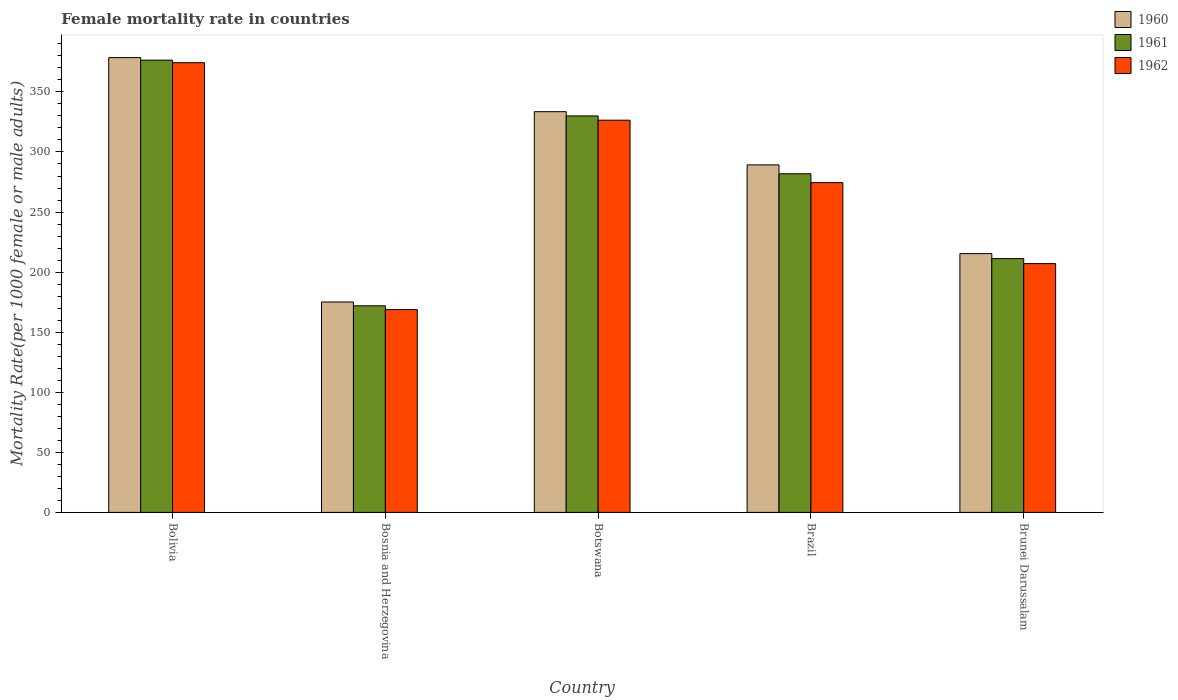How many different coloured bars are there?
Your answer should be very brief. 3. How many groups of bars are there?
Ensure brevity in your answer.  5. How many bars are there on the 4th tick from the right?
Your answer should be compact. 3. What is the label of the 1st group of bars from the left?
Ensure brevity in your answer.  Bolivia. What is the female mortality rate in 1961 in Brunei Darussalam?
Provide a short and direct response. 211.24. Across all countries, what is the maximum female mortality rate in 1961?
Provide a succinct answer. 376.43. Across all countries, what is the minimum female mortality rate in 1960?
Offer a terse response. 175.12. In which country was the female mortality rate in 1961 maximum?
Provide a short and direct response. Bolivia. In which country was the female mortality rate in 1961 minimum?
Ensure brevity in your answer.  Bosnia and Herzegovina. What is the total female mortality rate in 1961 in the graph?
Keep it short and to the point. 1371.52. What is the difference between the female mortality rate in 1961 in Botswana and that in Brazil?
Offer a very short reply. 48.13. What is the difference between the female mortality rate in 1960 in Brunei Darussalam and the female mortality rate in 1962 in Bosnia and Herzegovina?
Your answer should be very brief. 46.57. What is the average female mortality rate in 1962 per country?
Provide a succinct answer. 270.24. What is the difference between the female mortality rate of/in 1961 and female mortality rate of/in 1962 in Bolivia?
Offer a terse response. 2.11. What is the ratio of the female mortality rate in 1960 in Bolivia to that in Brazil?
Make the answer very short. 1.31. Is the difference between the female mortality rate in 1961 in Bolivia and Botswana greater than the difference between the female mortality rate in 1962 in Bolivia and Botswana?
Your response must be concise. No. What is the difference between the highest and the second highest female mortality rate in 1961?
Offer a very short reply. 46.43. What is the difference between the highest and the lowest female mortality rate in 1961?
Provide a short and direct response. 204.45. Is the sum of the female mortality rate in 1961 in Bolivia and Brunei Darussalam greater than the maximum female mortality rate in 1960 across all countries?
Ensure brevity in your answer.  Yes. What does the 3rd bar from the left in Botswana represents?
Offer a very short reply. 1962. What does the 1st bar from the right in Brunei Darussalam represents?
Keep it short and to the point. 1962. Is it the case that in every country, the sum of the female mortality rate in 1962 and female mortality rate in 1960 is greater than the female mortality rate in 1961?
Provide a short and direct response. Yes. How many bars are there?
Make the answer very short. 15. How many countries are there in the graph?
Provide a succinct answer. 5. Are the values on the major ticks of Y-axis written in scientific E-notation?
Ensure brevity in your answer.  No. How are the legend labels stacked?
Your answer should be very brief. Vertical. What is the title of the graph?
Offer a terse response. Female mortality rate in countries. Does "1964" appear as one of the legend labels in the graph?
Offer a terse response. No. What is the label or title of the Y-axis?
Make the answer very short. Mortality Rate(per 1000 female or male adults). What is the Mortality Rate(per 1000 female or male adults) in 1960 in Bolivia?
Provide a short and direct response. 378.54. What is the Mortality Rate(per 1000 female or male adults) in 1961 in Bolivia?
Give a very brief answer. 376.43. What is the Mortality Rate(per 1000 female or male adults) of 1962 in Bolivia?
Offer a terse response. 374.32. What is the Mortality Rate(per 1000 female or male adults) in 1960 in Bosnia and Herzegovina?
Give a very brief answer. 175.12. What is the Mortality Rate(per 1000 female or male adults) in 1961 in Bosnia and Herzegovina?
Your response must be concise. 171.98. What is the Mortality Rate(per 1000 female or male adults) in 1962 in Bosnia and Herzegovina?
Make the answer very short. 168.83. What is the Mortality Rate(per 1000 female or male adults) of 1960 in Botswana?
Ensure brevity in your answer.  333.54. What is the Mortality Rate(per 1000 female or male adults) of 1961 in Botswana?
Provide a succinct answer. 330. What is the Mortality Rate(per 1000 female or male adults) of 1962 in Botswana?
Your answer should be very brief. 326.45. What is the Mortality Rate(per 1000 female or male adults) in 1960 in Brazil?
Offer a very short reply. 289.25. What is the Mortality Rate(per 1000 female or male adults) in 1961 in Brazil?
Provide a short and direct response. 281.87. What is the Mortality Rate(per 1000 female or male adults) in 1962 in Brazil?
Give a very brief answer. 274.49. What is the Mortality Rate(per 1000 female or male adults) in 1960 in Brunei Darussalam?
Offer a very short reply. 215.4. What is the Mortality Rate(per 1000 female or male adults) in 1961 in Brunei Darussalam?
Keep it short and to the point. 211.24. What is the Mortality Rate(per 1000 female or male adults) in 1962 in Brunei Darussalam?
Offer a very short reply. 207.09. Across all countries, what is the maximum Mortality Rate(per 1000 female or male adults) in 1960?
Your answer should be compact. 378.54. Across all countries, what is the maximum Mortality Rate(per 1000 female or male adults) of 1961?
Give a very brief answer. 376.43. Across all countries, what is the maximum Mortality Rate(per 1000 female or male adults) of 1962?
Provide a succinct answer. 374.32. Across all countries, what is the minimum Mortality Rate(per 1000 female or male adults) in 1960?
Give a very brief answer. 175.12. Across all countries, what is the minimum Mortality Rate(per 1000 female or male adults) of 1961?
Give a very brief answer. 171.98. Across all countries, what is the minimum Mortality Rate(per 1000 female or male adults) in 1962?
Your answer should be compact. 168.83. What is the total Mortality Rate(per 1000 female or male adults) of 1960 in the graph?
Provide a short and direct response. 1391.86. What is the total Mortality Rate(per 1000 female or male adults) in 1961 in the graph?
Offer a terse response. 1371.52. What is the total Mortality Rate(per 1000 female or male adults) of 1962 in the graph?
Your answer should be compact. 1351.18. What is the difference between the Mortality Rate(per 1000 female or male adults) in 1960 in Bolivia and that in Bosnia and Herzegovina?
Provide a succinct answer. 203.42. What is the difference between the Mortality Rate(per 1000 female or male adults) of 1961 in Bolivia and that in Bosnia and Herzegovina?
Provide a short and direct response. 204.45. What is the difference between the Mortality Rate(per 1000 female or male adults) in 1962 in Bolivia and that in Bosnia and Herzegovina?
Your answer should be compact. 205.49. What is the difference between the Mortality Rate(per 1000 female or male adults) in 1960 in Bolivia and that in Botswana?
Make the answer very short. 45. What is the difference between the Mortality Rate(per 1000 female or male adults) of 1961 in Bolivia and that in Botswana?
Make the answer very short. 46.43. What is the difference between the Mortality Rate(per 1000 female or male adults) in 1962 in Bolivia and that in Botswana?
Keep it short and to the point. 47.86. What is the difference between the Mortality Rate(per 1000 female or male adults) in 1960 in Bolivia and that in Brazil?
Keep it short and to the point. 89.29. What is the difference between the Mortality Rate(per 1000 female or male adults) in 1961 in Bolivia and that in Brazil?
Your answer should be very brief. 94.56. What is the difference between the Mortality Rate(per 1000 female or male adults) of 1962 in Bolivia and that in Brazil?
Give a very brief answer. 99.83. What is the difference between the Mortality Rate(per 1000 female or male adults) of 1960 in Bolivia and that in Brunei Darussalam?
Provide a short and direct response. 163.14. What is the difference between the Mortality Rate(per 1000 female or male adults) of 1961 in Bolivia and that in Brunei Darussalam?
Offer a terse response. 165.19. What is the difference between the Mortality Rate(per 1000 female or male adults) in 1962 in Bolivia and that in Brunei Darussalam?
Your answer should be compact. 167.23. What is the difference between the Mortality Rate(per 1000 female or male adults) of 1960 in Bosnia and Herzegovina and that in Botswana?
Your answer should be very brief. -158.42. What is the difference between the Mortality Rate(per 1000 female or male adults) in 1961 in Bosnia and Herzegovina and that in Botswana?
Keep it short and to the point. -158.02. What is the difference between the Mortality Rate(per 1000 female or male adults) of 1962 in Bosnia and Herzegovina and that in Botswana?
Your response must be concise. -157.62. What is the difference between the Mortality Rate(per 1000 female or male adults) in 1960 in Bosnia and Herzegovina and that in Brazil?
Provide a succinct answer. -114.13. What is the difference between the Mortality Rate(per 1000 female or male adults) in 1961 in Bosnia and Herzegovina and that in Brazil?
Your answer should be very brief. -109.9. What is the difference between the Mortality Rate(per 1000 female or male adults) in 1962 in Bosnia and Herzegovina and that in Brazil?
Your answer should be compact. -105.66. What is the difference between the Mortality Rate(per 1000 female or male adults) of 1960 in Bosnia and Herzegovina and that in Brunei Darussalam?
Offer a terse response. -40.27. What is the difference between the Mortality Rate(per 1000 female or male adults) in 1961 in Bosnia and Herzegovina and that in Brunei Darussalam?
Ensure brevity in your answer.  -39.27. What is the difference between the Mortality Rate(per 1000 female or male adults) in 1962 in Bosnia and Herzegovina and that in Brunei Darussalam?
Give a very brief answer. -38.26. What is the difference between the Mortality Rate(per 1000 female or male adults) in 1960 in Botswana and that in Brazil?
Your response must be concise. 44.29. What is the difference between the Mortality Rate(per 1000 female or male adults) in 1961 in Botswana and that in Brazil?
Offer a very short reply. 48.13. What is the difference between the Mortality Rate(per 1000 female or male adults) of 1962 in Botswana and that in Brazil?
Ensure brevity in your answer.  51.96. What is the difference between the Mortality Rate(per 1000 female or male adults) in 1960 in Botswana and that in Brunei Darussalam?
Offer a terse response. 118.14. What is the difference between the Mortality Rate(per 1000 female or male adults) of 1961 in Botswana and that in Brunei Darussalam?
Your answer should be very brief. 118.76. What is the difference between the Mortality Rate(per 1000 female or male adults) of 1962 in Botswana and that in Brunei Darussalam?
Make the answer very short. 119.37. What is the difference between the Mortality Rate(per 1000 female or male adults) of 1960 in Brazil and that in Brunei Darussalam?
Give a very brief answer. 73.86. What is the difference between the Mortality Rate(per 1000 female or male adults) of 1961 in Brazil and that in Brunei Darussalam?
Offer a terse response. 70.63. What is the difference between the Mortality Rate(per 1000 female or male adults) in 1962 in Brazil and that in Brunei Darussalam?
Provide a short and direct response. 67.41. What is the difference between the Mortality Rate(per 1000 female or male adults) of 1960 in Bolivia and the Mortality Rate(per 1000 female or male adults) of 1961 in Bosnia and Herzegovina?
Your response must be concise. 206.57. What is the difference between the Mortality Rate(per 1000 female or male adults) in 1960 in Bolivia and the Mortality Rate(per 1000 female or male adults) in 1962 in Bosnia and Herzegovina?
Make the answer very short. 209.71. What is the difference between the Mortality Rate(per 1000 female or male adults) of 1961 in Bolivia and the Mortality Rate(per 1000 female or male adults) of 1962 in Bosnia and Herzegovina?
Offer a very short reply. 207.6. What is the difference between the Mortality Rate(per 1000 female or male adults) of 1960 in Bolivia and the Mortality Rate(per 1000 female or male adults) of 1961 in Botswana?
Give a very brief answer. 48.54. What is the difference between the Mortality Rate(per 1000 female or male adults) of 1960 in Bolivia and the Mortality Rate(per 1000 female or male adults) of 1962 in Botswana?
Give a very brief answer. 52.09. What is the difference between the Mortality Rate(per 1000 female or male adults) in 1961 in Bolivia and the Mortality Rate(per 1000 female or male adults) in 1962 in Botswana?
Make the answer very short. 49.98. What is the difference between the Mortality Rate(per 1000 female or male adults) of 1960 in Bolivia and the Mortality Rate(per 1000 female or male adults) of 1961 in Brazil?
Your answer should be compact. 96.67. What is the difference between the Mortality Rate(per 1000 female or male adults) of 1960 in Bolivia and the Mortality Rate(per 1000 female or male adults) of 1962 in Brazil?
Give a very brief answer. 104.05. What is the difference between the Mortality Rate(per 1000 female or male adults) of 1961 in Bolivia and the Mortality Rate(per 1000 female or male adults) of 1962 in Brazil?
Your answer should be compact. 101.94. What is the difference between the Mortality Rate(per 1000 female or male adults) in 1960 in Bolivia and the Mortality Rate(per 1000 female or male adults) in 1961 in Brunei Darussalam?
Give a very brief answer. 167.3. What is the difference between the Mortality Rate(per 1000 female or male adults) of 1960 in Bolivia and the Mortality Rate(per 1000 female or male adults) of 1962 in Brunei Darussalam?
Keep it short and to the point. 171.46. What is the difference between the Mortality Rate(per 1000 female or male adults) in 1961 in Bolivia and the Mortality Rate(per 1000 female or male adults) in 1962 in Brunei Darussalam?
Make the answer very short. 169.34. What is the difference between the Mortality Rate(per 1000 female or male adults) in 1960 in Bosnia and Herzegovina and the Mortality Rate(per 1000 female or male adults) in 1961 in Botswana?
Make the answer very short. -154.88. What is the difference between the Mortality Rate(per 1000 female or male adults) in 1960 in Bosnia and Herzegovina and the Mortality Rate(per 1000 female or male adults) in 1962 in Botswana?
Your answer should be very brief. -151.33. What is the difference between the Mortality Rate(per 1000 female or male adults) in 1961 in Bosnia and Herzegovina and the Mortality Rate(per 1000 female or male adults) in 1962 in Botswana?
Provide a succinct answer. -154.48. What is the difference between the Mortality Rate(per 1000 female or male adults) in 1960 in Bosnia and Herzegovina and the Mortality Rate(per 1000 female or male adults) in 1961 in Brazil?
Ensure brevity in your answer.  -106.75. What is the difference between the Mortality Rate(per 1000 female or male adults) of 1960 in Bosnia and Herzegovina and the Mortality Rate(per 1000 female or male adults) of 1962 in Brazil?
Give a very brief answer. -99.37. What is the difference between the Mortality Rate(per 1000 female or male adults) of 1961 in Bosnia and Herzegovina and the Mortality Rate(per 1000 female or male adults) of 1962 in Brazil?
Provide a succinct answer. -102.52. What is the difference between the Mortality Rate(per 1000 female or male adults) of 1960 in Bosnia and Herzegovina and the Mortality Rate(per 1000 female or male adults) of 1961 in Brunei Darussalam?
Provide a short and direct response. -36.12. What is the difference between the Mortality Rate(per 1000 female or male adults) of 1960 in Bosnia and Herzegovina and the Mortality Rate(per 1000 female or male adults) of 1962 in Brunei Darussalam?
Provide a short and direct response. -31.96. What is the difference between the Mortality Rate(per 1000 female or male adults) in 1961 in Bosnia and Herzegovina and the Mortality Rate(per 1000 female or male adults) in 1962 in Brunei Darussalam?
Your answer should be very brief. -35.11. What is the difference between the Mortality Rate(per 1000 female or male adults) of 1960 in Botswana and the Mortality Rate(per 1000 female or male adults) of 1961 in Brazil?
Your answer should be very brief. 51.67. What is the difference between the Mortality Rate(per 1000 female or male adults) of 1960 in Botswana and the Mortality Rate(per 1000 female or male adults) of 1962 in Brazil?
Provide a short and direct response. 59.05. What is the difference between the Mortality Rate(per 1000 female or male adults) in 1961 in Botswana and the Mortality Rate(per 1000 female or male adults) in 1962 in Brazil?
Your response must be concise. 55.51. What is the difference between the Mortality Rate(per 1000 female or male adults) of 1960 in Botswana and the Mortality Rate(per 1000 female or male adults) of 1961 in Brunei Darussalam?
Offer a very short reply. 122.3. What is the difference between the Mortality Rate(per 1000 female or male adults) in 1960 in Botswana and the Mortality Rate(per 1000 female or male adults) in 1962 in Brunei Darussalam?
Offer a very short reply. 126.46. What is the difference between the Mortality Rate(per 1000 female or male adults) of 1961 in Botswana and the Mortality Rate(per 1000 female or male adults) of 1962 in Brunei Darussalam?
Your answer should be compact. 122.91. What is the difference between the Mortality Rate(per 1000 female or male adults) of 1960 in Brazil and the Mortality Rate(per 1000 female or male adults) of 1961 in Brunei Darussalam?
Offer a very short reply. 78.01. What is the difference between the Mortality Rate(per 1000 female or male adults) of 1960 in Brazil and the Mortality Rate(per 1000 female or male adults) of 1962 in Brunei Darussalam?
Give a very brief answer. 82.17. What is the difference between the Mortality Rate(per 1000 female or male adults) in 1961 in Brazil and the Mortality Rate(per 1000 female or male adults) in 1962 in Brunei Darussalam?
Your answer should be very brief. 74.79. What is the average Mortality Rate(per 1000 female or male adults) of 1960 per country?
Offer a very short reply. 278.37. What is the average Mortality Rate(per 1000 female or male adults) in 1961 per country?
Your answer should be compact. 274.3. What is the average Mortality Rate(per 1000 female or male adults) of 1962 per country?
Ensure brevity in your answer.  270.24. What is the difference between the Mortality Rate(per 1000 female or male adults) of 1960 and Mortality Rate(per 1000 female or male adults) of 1961 in Bolivia?
Offer a very short reply. 2.11. What is the difference between the Mortality Rate(per 1000 female or male adults) of 1960 and Mortality Rate(per 1000 female or male adults) of 1962 in Bolivia?
Make the answer very short. 4.22. What is the difference between the Mortality Rate(per 1000 female or male adults) in 1961 and Mortality Rate(per 1000 female or male adults) in 1962 in Bolivia?
Make the answer very short. 2.11. What is the difference between the Mortality Rate(per 1000 female or male adults) in 1960 and Mortality Rate(per 1000 female or male adults) in 1961 in Bosnia and Herzegovina?
Give a very brief answer. 3.15. What is the difference between the Mortality Rate(per 1000 female or male adults) in 1960 and Mortality Rate(per 1000 female or male adults) in 1962 in Bosnia and Herzegovina?
Your answer should be very brief. 6.29. What is the difference between the Mortality Rate(per 1000 female or male adults) of 1961 and Mortality Rate(per 1000 female or male adults) of 1962 in Bosnia and Herzegovina?
Your answer should be very brief. 3.15. What is the difference between the Mortality Rate(per 1000 female or male adults) in 1960 and Mortality Rate(per 1000 female or male adults) in 1961 in Botswana?
Ensure brevity in your answer.  3.54. What is the difference between the Mortality Rate(per 1000 female or male adults) of 1960 and Mortality Rate(per 1000 female or male adults) of 1962 in Botswana?
Ensure brevity in your answer.  7.09. What is the difference between the Mortality Rate(per 1000 female or male adults) in 1961 and Mortality Rate(per 1000 female or male adults) in 1962 in Botswana?
Give a very brief answer. 3.54. What is the difference between the Mortality Rate(per 1000 female or male adults) in 1960 and Mortality Rate(per 1000 female or male adults) in 1961 in Brazil?
Offer a very short reply. 7.38. What is the difference between the Mortality Rate(per 1000 female or male adults) of 1960 and Mortality Rate(per 1000 female or male adults) of 1962 in Brazil?
Offer a terse response. 14.76. What is the difference between the Mortality Rate(per 1000 female or male adults) in 1961 and Mortality Rate(per 1000 female or male adults) in 1962 in Brazil?
Provide a succinct answer. 7.38. What is the difference between the Mortality Rate(per 1000 female or male adults) in 1960 and Mortality Rate(per 1000 female or male adults) in 1961 in Brunei Darussalam?
Your answer should be compact. 4.16. What is the difference between the Mortality Rate(per 1000 female or male adults) in 1960 and Mortality Rate(per 1000 female or male adults) in 1962 in Brunei Darussalam?
Make the answer very short. 8.31. What is the difference between the Mortality Rate(per 1000 female or male adults) of 1961 and Mortality Rate(per 1000 female or male adults) of 1962 in Brunei Darussalam?
Provide a short and direct response. 4.16. What is the ratio of the Mortality Rate(per 1000 female or male adults) of 1960 in Bolivia to that in Bosnia and Herzegovina?
Keep it short and to the point. 2.16. What is the ratio of the Mortality Rate(per 1000 female or male adults) in 1961 in Bolivia to that in Bosnia and Herzegovina?
Make the answer very short. 2.19. What is the ratio of the Mortality Rate(per 1000 female or male adults) in 1962 in Bolivia to that in Bosnia and Herzegovina?
Provide a short and direct response. 2.22. What is the ratio of the Mortality Rate(per 1000 female or male adults) in 1960 in Bolivia to that in Botswana?
Provide a succinct answer. 1.13. What is the ratio of the Mortality Rate(per 1000 female or male adults) of 1961 in Bolivia to that in Botswana?
Make the answer very short. 1.14. What is the ratio of the Mortality Rate(per 1000 female or male adults) in 1962 in Bolivia to that in Botswana?
Your answer should be very brief. 1.15. What is the ratio of the Mortality Rate(per 1000 female or male adults) of 1960 in Bolivia to that in Brazil?
Keep it short and to the point. 1.31. What is the ratio of the Mortality Rate(per 1000 female or male adults) of 1961 in Bolivia to that in Brazil?
Make the answer very short. 1.34. What is the ratio of the Mortality Rate(per 1000 female or male adults) of 1962 in Bolivia to that in Brazil?
Keep it short and to the point. 1.36. What is the ratio of the Mortality Rate(per 1000 female or male adults) of 1960 in Bolivia to that in Brunei Darussalam?
Provide a succinct answer. 1.76. What is the ratio of the Mortality Rate(per 1000 female or male adults) of 1961 in Bolivia to that in Brunei Darussalam?
Offer a terse response. 1.78. What is the ratio of the Mortality Rate(per 1000 female or male adults) in 1962 in Bolivia to that in Brunei Darussalam?
Offer a very short reply. 1.81. What is the ratio of the Mortality Rate(per 1000 female or male adults) of 1960 in Bosnia and Herzegovina to that in Botswana?
Provide a succinct answer. 0.53. What is the ratio of the Mortality Rate(per 1000 female or male adults) of 1961 in Bosnia and Herzegovina to that in Botswana?
Your answer should be very brief. 0.52. What is the ratio of the Mortality Rate(per 1000 female or male adults) in 1962 in Bosnia and Herzegovina to that in Botswana?
Your response must be concise. 0.52. What is the ratio of the Mortality Rate(per 1000 female or male adults) of 1960 in Bosnia and Herzegovina to that in Brazil?
Provide a succinct answer. 0.61. What is the ratio of the Mortality Rate(per 1000 female or male adults) of 1961 in Bosnia and Herzegovina to that in Brazil?
Ensure brevity in your answer.  0.61. What is the ratio of the Mortality Rate(per 1000 female or male adults) of 1962 in Bosnia and Herzegovina to that in Brazil?
Give a very brief answer. 0.62. What is the ratio of the Mortality Rate(per 1000 female or male adults) of 1960 in Bosnia and Herzegovina to that in Brunei Darussalam?
Provide a succinct answer. 0.81. What is the ratio of the Mortality Rate(per 1000 female or male adults) of 1961 in Bosnia and Herzegovina to that in Brunei Darussalam?
Offer a very short reply. 0.81. What is the ratio of the Mortality Rate(per 1000 female or male adults) in 1962 in Bosnia and Herzegovina to that in Brunei Darussalam?
Provide a succinct answer. 0.82. What is the ratio of the Mortality Rate(per 1000 female or male adults) of 1960 in Botswana to that in Brazil?
Offer a very short reply. 1.15. What is the ratio of the Mortality Rate(per 1000 female or male adults) in 1961 in Botswana to that in Brazil?
Your answer should be very brief. 1.17. What is the ratio of the Mortality Rate(per 1000 female or male adults) of 1962 in Botswana to that in Brazil?
Your answer should be compact. 1.19. What is the ratio of the Mortality Rate(per 1000 female or male adults) in 1960 in Botswana to that in Brunei Darussalam?
Give a very brief answer. 1.55. What is the ratio of the Mortality Rate(per 1000 female or male adults) of 1961 in Botswana to that in Brunei Darussalam?
Ensure brevity in your answer.  1.56. What is the ratio of the Mortality Rate(per 1000 female or male adults) in 1962 in Botswana to that in Brunei Darussalam?
Your response must be concise. 1.58. What is the ratio of the Mortality Rate(per 1000 female or male adults) in 1960 in Brazil to that in Brunei Darussalam?
Make the answer very short. 1.34. What is the ratio of the Mortality Rate(per 1000 female or male adults) of 1961 in Brazil to that in Brunei Darussalam?
Your response must be concise. 1.33. What is the ratio of the Mortality Rate(per 1000 female or male adults) of 1962 in Brazil to that in Brunei Darussalam?
Offer a terse response. 1.33. What is the difference between the highest and the second highest Mortality Rate(per 1000 female or male adults) of 1960?
Give a very brief answer. 45. What is the difference between the highest and the second highest Mortality Rate(per 1000 female or male adults) of 1961?
Your response must be concise. 46.43. What is the difference between the highest and the second highest Mortality Rate(per 1000 female or male adults) of 1962?
Your response must be concise. 47.86. What is the difference between the highest and the lowest Mortality Rate(per 1000 female or male adults) in 1960?
Offer a terse response. 203.42. What is the difference between the highest and the lowest Mortality Rate(per 1000 female or male adults) in 1961?
Your response must be concise. 204.45. What is the difference between the highest and the lowest Mortality Rate(per 1000 female or male adults) in 1962?
Give a very brief answer. 205.49. 